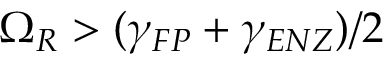Convert formula to latex. <formula><loc_0><loc_0><loc_500><loc_500>\Omega _ { R } > ( \gamma _ { F P } + \gamma _ { E N Z } ) / 2</formula> 